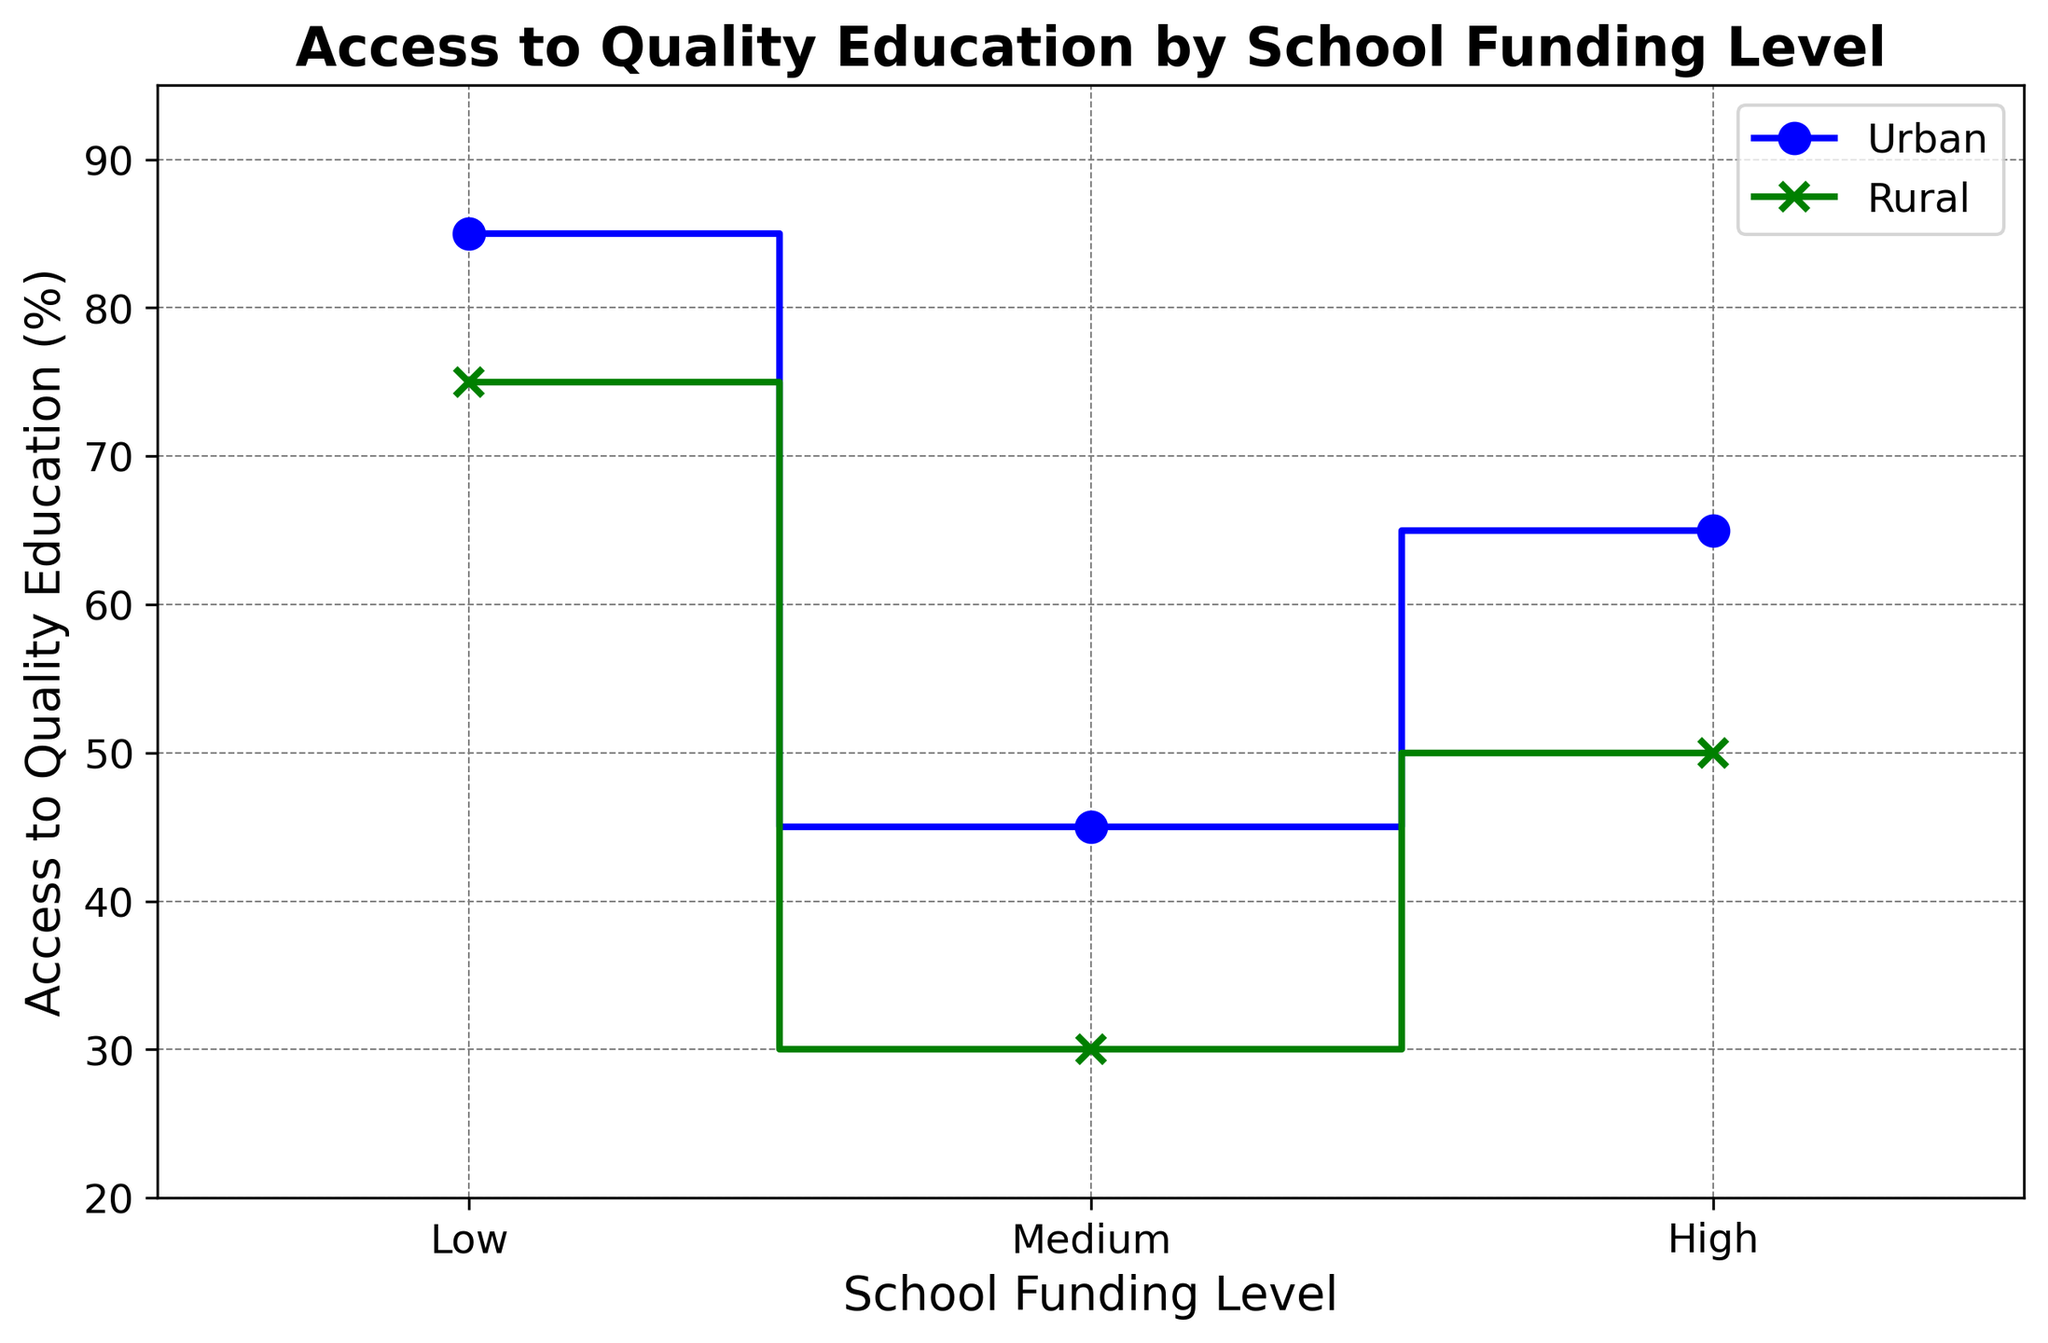What is the access to quality education in urban areas with low funding? In urban areas, the access to quality education with low funding is indicated by the first marker on the blue line, which corresponds to 45%.
Answer: 45% How does access to quality education in rural areas with high funding compare to urban areas with high funding? The figures show access to quality education is 75% in rural areas with high funding and 85% in urban areas with high funding. Thereby, urban areas with high funding have higher access levels by 10%.
Answer: Higher in urban areas by 10% What is the general trend of access to quality education in both urban and rural areas as school funding levels increase? The trend for both urban and rural areas shows an increase in access to quality education as school funding levels go from low to high.
Answer: Increases Find the average access to quality education in urban areas across all funding levels. For urban areas, access levels are 45% (Low), 65% (Medium), and 85% (High). The average is calculated as (45 + 65 + 85) / 3 = 195 / 3 = 65%.
Answer: 65% Which funding level shows the biggest difference in access to quality education between urban and rural areas? The differences between urban and rural access levels are 15% for Low (45% - 30%), 15% for Medium (65% - 50%), and 10% for High (85% - 75%). Therefore, either Low or Medium shows the biggest difference of 15%.
Answer: Low and Medium (both 15%) If the school funding level increases from low to medium, by how much does access to quality education increase in rural areas? In rural areas, access increases from 30% (Low) to 50% (Medium). The increase is calculated as 50 - 30 = 20%.
Answer: 20% What color represents the urban areas in the plot, and what marker is used for these areas? The urban areas are represented by the blue line with circular markers (o).
Answer: Blue, circular markers Compare the increase in access to quality education when school funding increases from medium to high in urban areas versus rural areas. In urban areas, the increase is 85% - 65% = 20%. In rural areas, the increase is 75% - 50% = 25%. Therefore, the increase is greater in rural areas by 5%.
Answer: Greater in rural areas by 5% What is the access to quality education in rural areas with low funding? In rural areas, the access to quality education with low funding is indicated by the first marker on the green line, which corresponds to 30%.
Answer: 30% What is the minimum value of access to quality education in urban areas? The minimum value for urban areas is indicated by the lowest point on the blue line, which is 45%.
Answer: 45% 